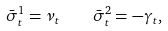Convert formula to latex. <formula><loc_0><loc_0><loc_500><loc_500>\bar { \sigma } ^ { 1 } _ { t } = \nu _ { t } \quad \bar { \sigma } ^ { 2 } _ { t } = - \gamma _ { t } ,</formula> 